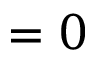<formula> <loc_0><loc_0><loc_500><loc_500>= 0</formula> 